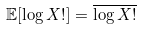Convert formula to latex. <formula><loc_0><loc_0><loc_500><loc_500>\mathbb { E } [ \log X ! ] = \overline { \log X ! }</formula> 